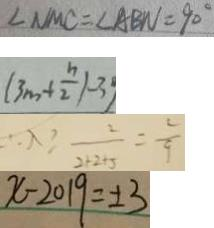Convert formula to latex. <formula><loc_0><loc_0><loc_500><loc_500>\angle N M C = \angle A B N = 9 0 ^ { \circ } 
 ( 3 m + \frac { n } { 2 } ) - 3 
 \therefore \lambda \geq \frac { 2 } { 2 + 2 + 5 } = \frac { 2 } { 9 } 
 x - 2 0 1 9 = \pm 3</formula> 